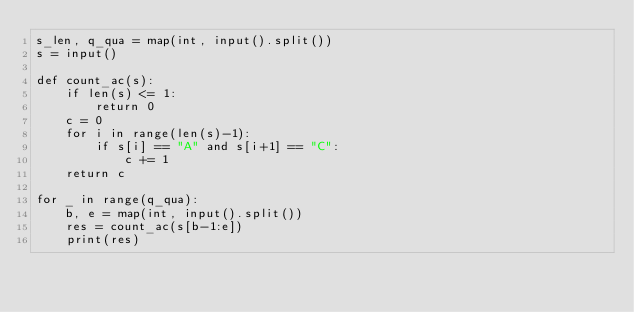Convert code to text. <code><loc_0><loc_0><loc_500><loc_500><_Python_>s_len, q_qua = map(int, input().split())
s = input()

def count_ac(s):
    if len(s) <= 1:
        return 0
    c = 0
    for i in range(len(s)-1):
        if s[i] == "A" and s[i+1] == "C":
            c += 1
    return c

for _ in range(q_qua):
    b, e = map(int, input().split())
    res = count_ac(s[b-1:e])
    print(res)</code> 